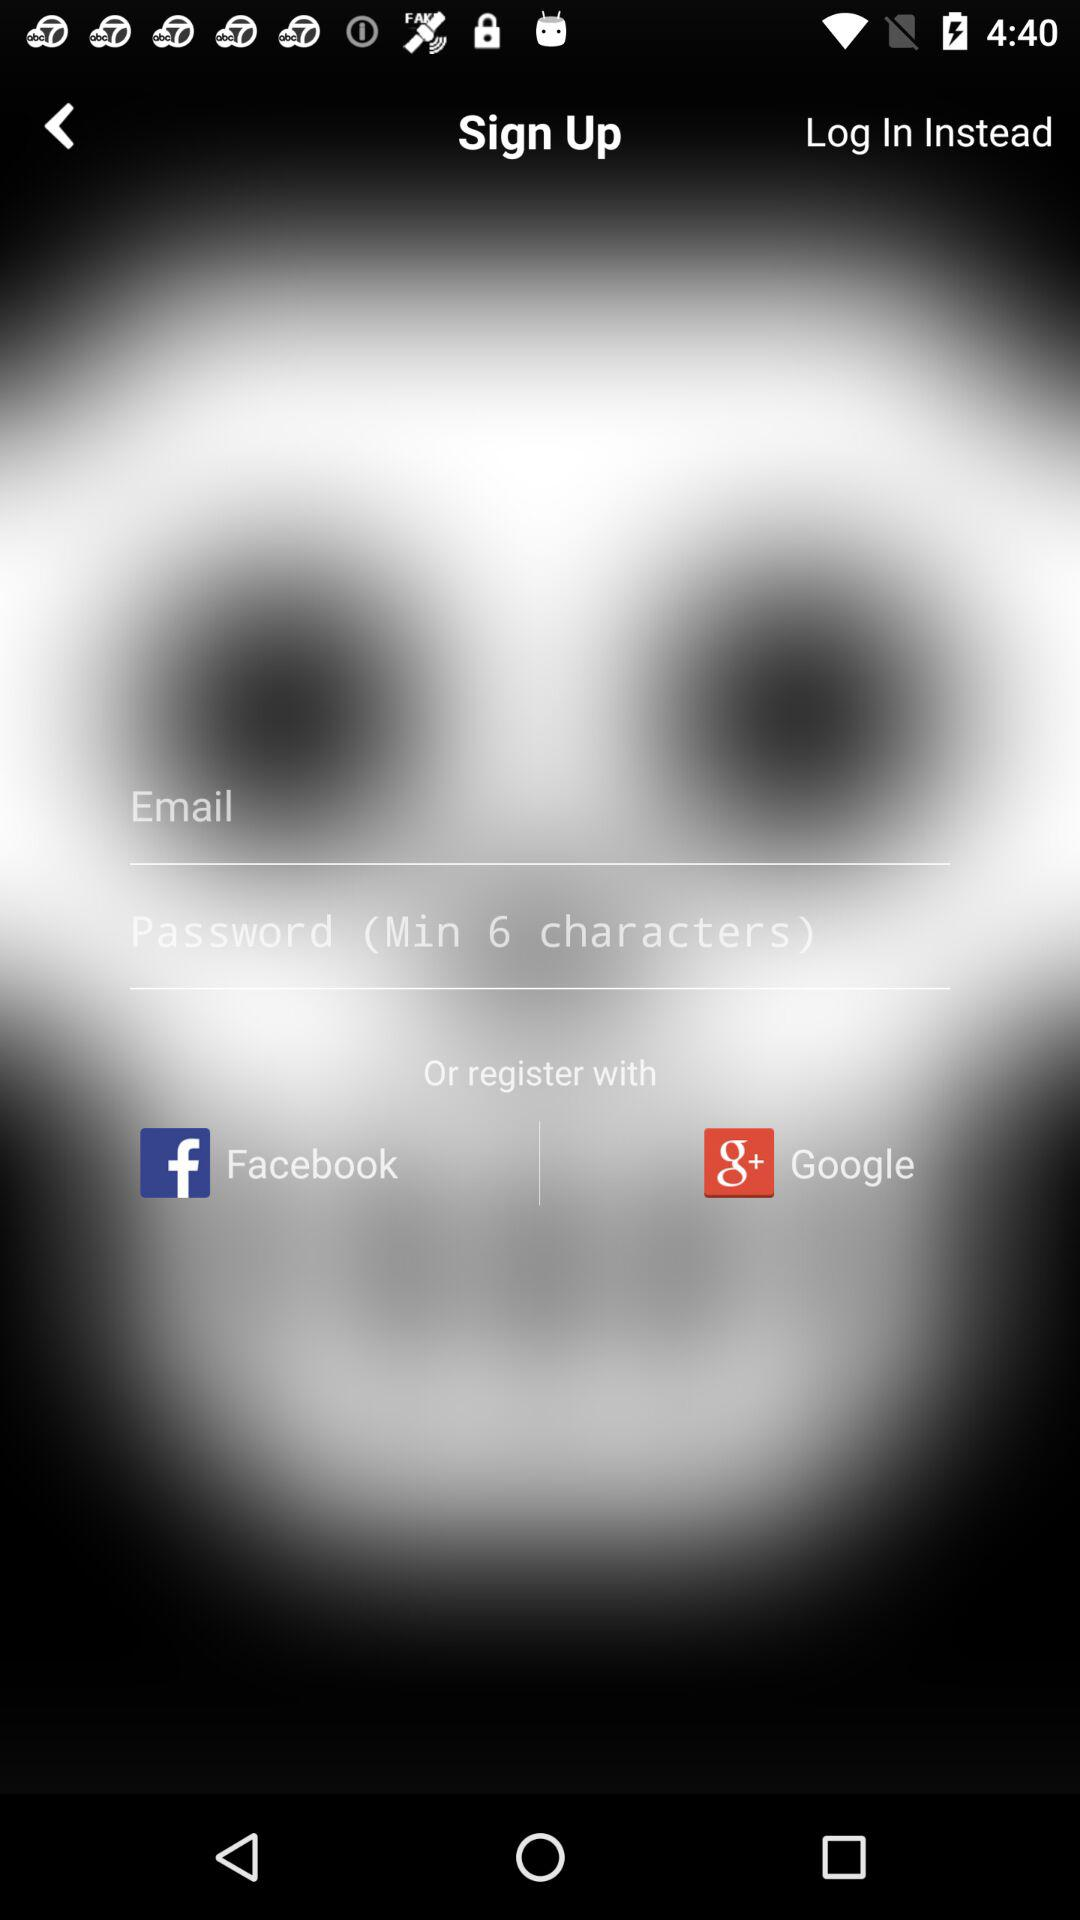How many inputs are there on the sign up screen?
Answer the question using a single word or phrase. 2 